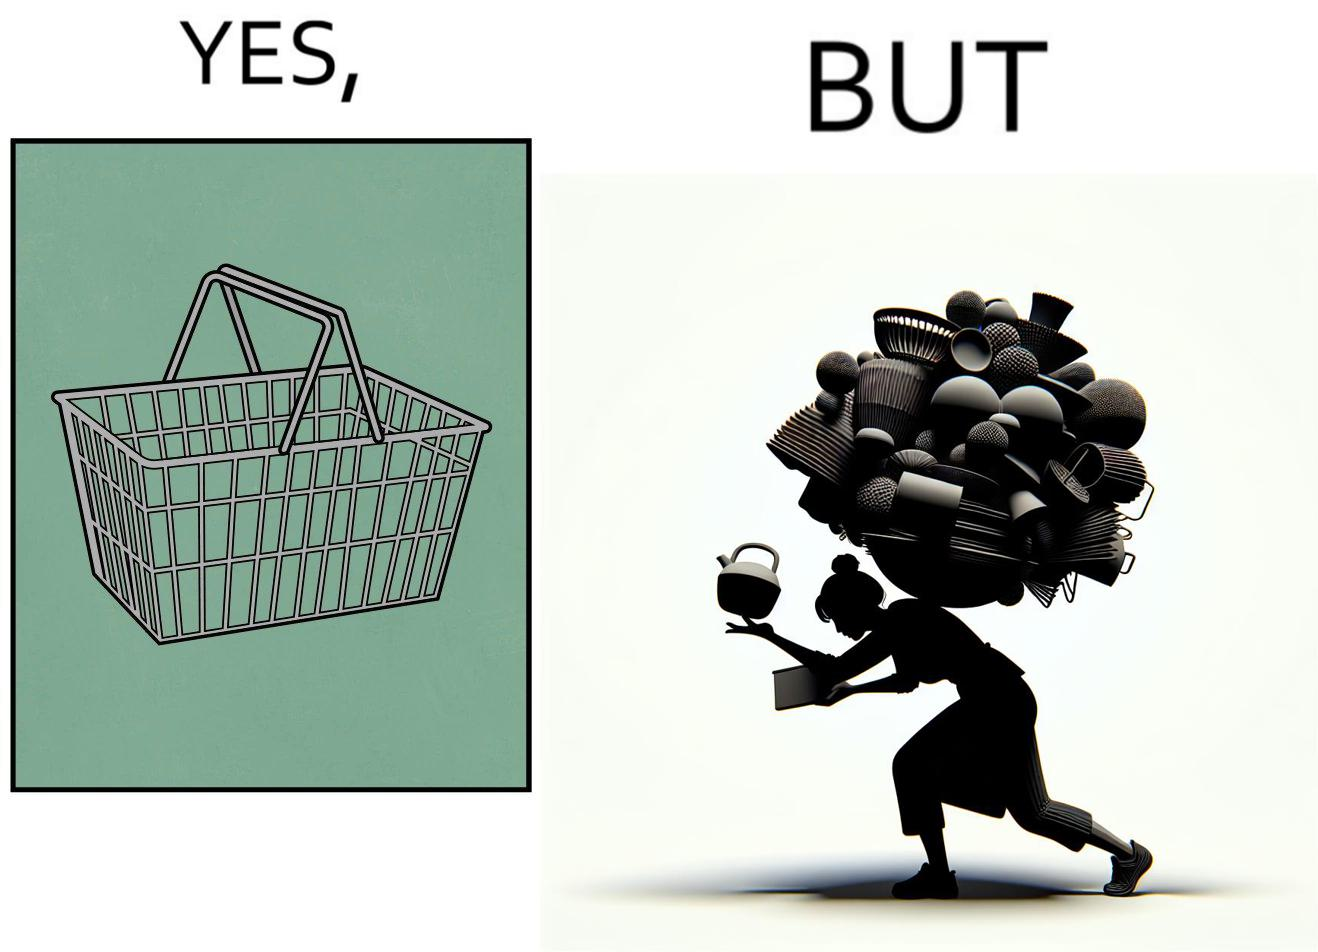What is the satirical meaning behind this image? The image is ironic, because even when there are steel frame baskets are available at the supermarkets people prefer carrying the items in hand 